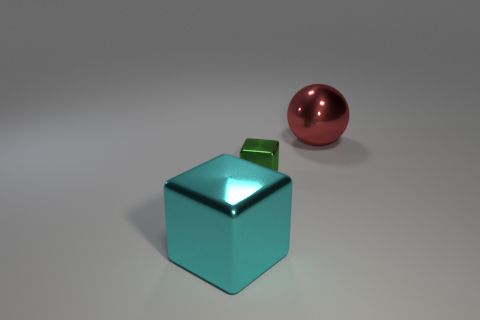There is a metallic thing on the right side of the green block; is it the same size as the big cyan object?
Keep it short and to the point. Yes. How many green objects are either metallic objects or cubes?
Your answer should be very brief. 1. There is a object in front of the green metal object; what number of things are behind it?
Offer a terse response. 2. How many big cyan objects have the same shape as the green shiny object?
Provide a succinct answer. 1. What number of big yellow spheres are there?
Provide a short and direct response. 0. There is a metallic block that is in front of the small object; what is its color?
Provide a succinct answer. Cyan. What is the color of the thing to the left of the shiny block that is right of the large cyan shiny cube?
Ensure brevity in your answer.  Cyan. The metal object that is the same size as the sphere is what color?
Your answer should be compact. Cyan. What number of things are both in front of the big red metal ball and on the right side of the big cyan block?
Make the answer very short. 1. The thing that is in front of the big sphere and on the right side of the large cyan metallic object is made of what material?
Offer a terse response. Metal. 